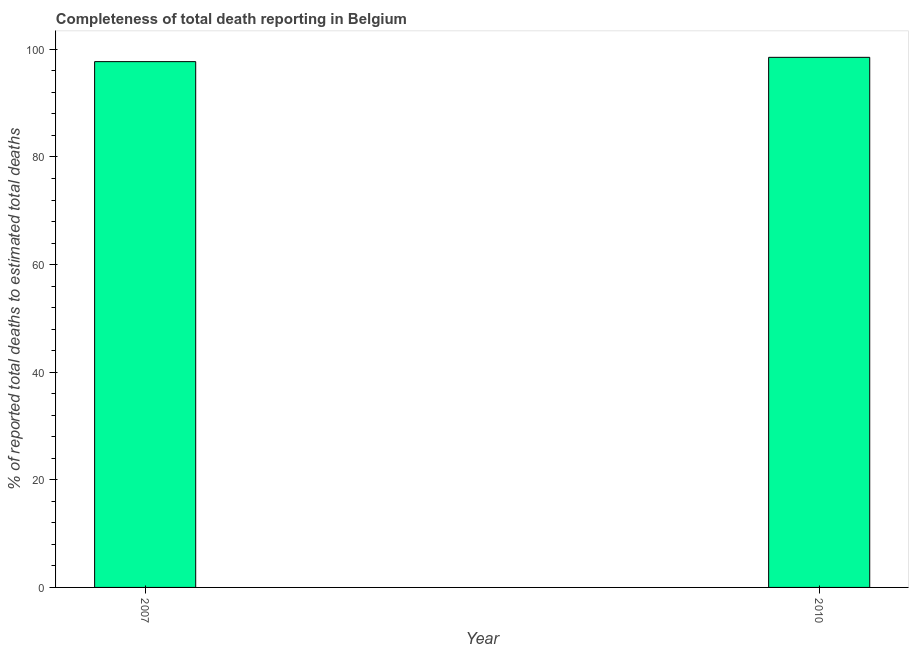Does the graph contain any zero values?
Offer a terse response. No. Does the graph contain grids?
Ensure brevity in your answer.  No. What is the title of the graph?
Offer a very short reply. Completeness of total death reporting in Belgium. What is the label or title of the Y-axis?
Offer a very short reply. % of reported total deaths to estimated total deaths. What is the completeness of total death reports in 2010?
Keep it short and to the point. 98.52. Across all years, what is the maximum completeness of total death reports?
Your answer should be compact. 98.52. Across all years, what is the minimum completeness of total death reports?
Make the answer very short. 97.72. In which year was the completeness of total death reports maximum?
Your answer should be compact. 2010. In which year was the completeness of total death reports minimum?
Your response must be concise. 2007. What is the sum of the completeness of total death reports?
Your answer should be compact. 196.24. What is the difference between the completeness of total death reports in 2007 and 2010?
Make the answer very short. -0.8. What is the average completeness of total death reports per year?
Your response must be concise. 98.12. What is the median completeness of total death reports?
Your answer should be very brief. 98.12. In how many years, is the completeness of total death reports greater than 60 %?
Your answer should be very brief. 2. Do a majority of the years between 2010 and 2007 (inclusive) have completeness of total death reports greater than 28 %?
Provide a succinct answer. No. What is the ratio of the completeness of total death reports in 2007 to that in 2010?
Your answer should be compact. 0.99. Is the completeness of total death reports in 2007 less than that in 2010?
Offer a very short reply. Yes. In how many years, is the completeness of total death reports greater than the average completeness of total death reports taken over all years?
Make the answer very short. 1. Are all the bars in the graph horizontal?
Provide a short and direct response. No. What is the difference between two consecutive major ticks on the Y-axis?
Your answer should be compact. 20. What is the % of reported total deaths to estimated total deaths of 2007?
Make the answer very short. 97.72. What is the % of reported total deaths to estimated total deaths of 2010?
Ensure brevity in your answer.  98.52. What is the difference between the % of reported total deaths to estimated total deaths in 2007 and 2010?
Give a very brief answer. -0.8. 